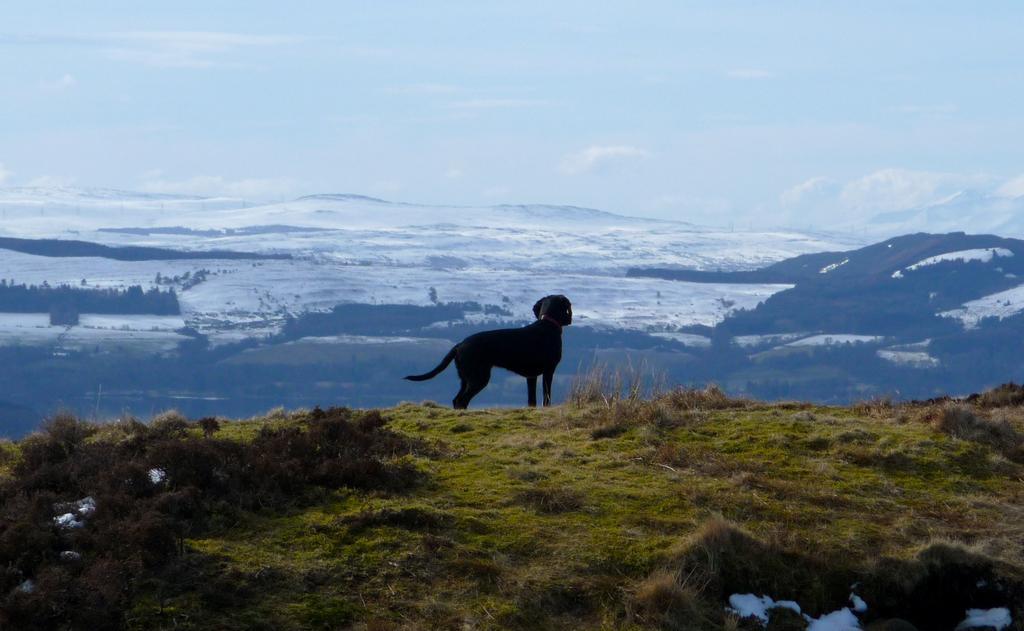Please provide a concise description of this image. In this image, we can see a black dog standing. At the bottom of the image, we can see plants, grass and snow. In the background, we can see the hills, snow, trees and sky. 